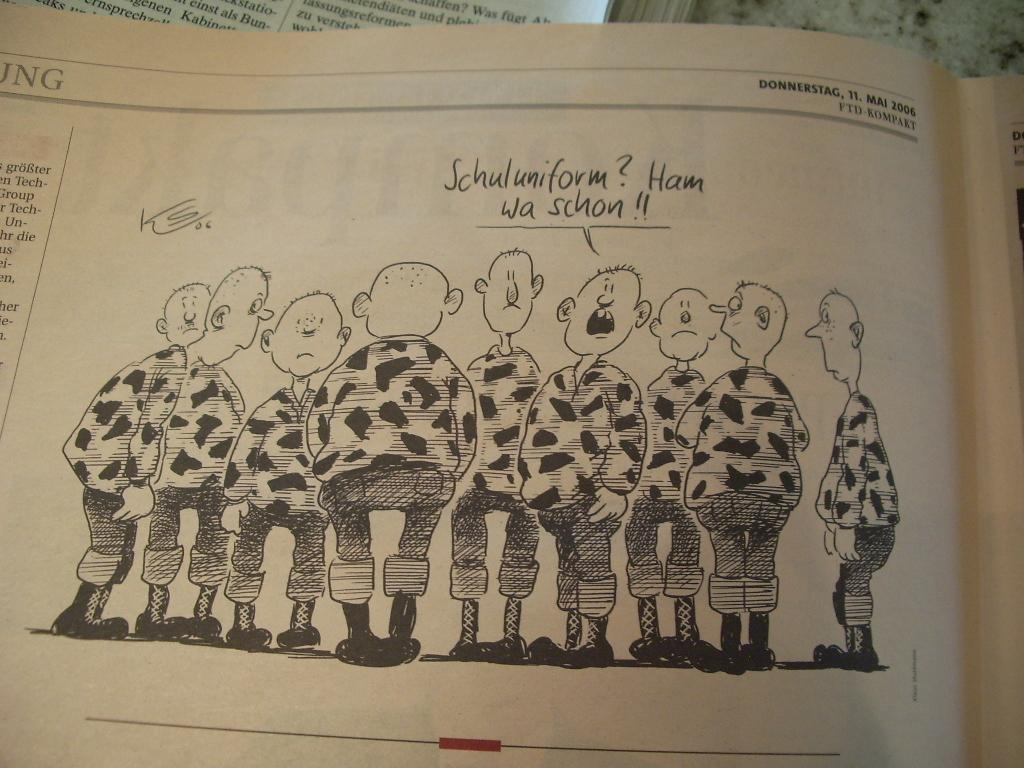What is present in the image that can be written on? There is a paper in the image that can be written on. Can you describe the people in the image? There is a group of people standing in the image. What is written on the paper? There is writing on the paper. What type of berry is being used as an example in the image? There is no berry present in the image, and therefore no example involving a berry can be observed. Is there a baseball game happening in the image? There is no mention of a baseball game or any sports-related activity in the image. 